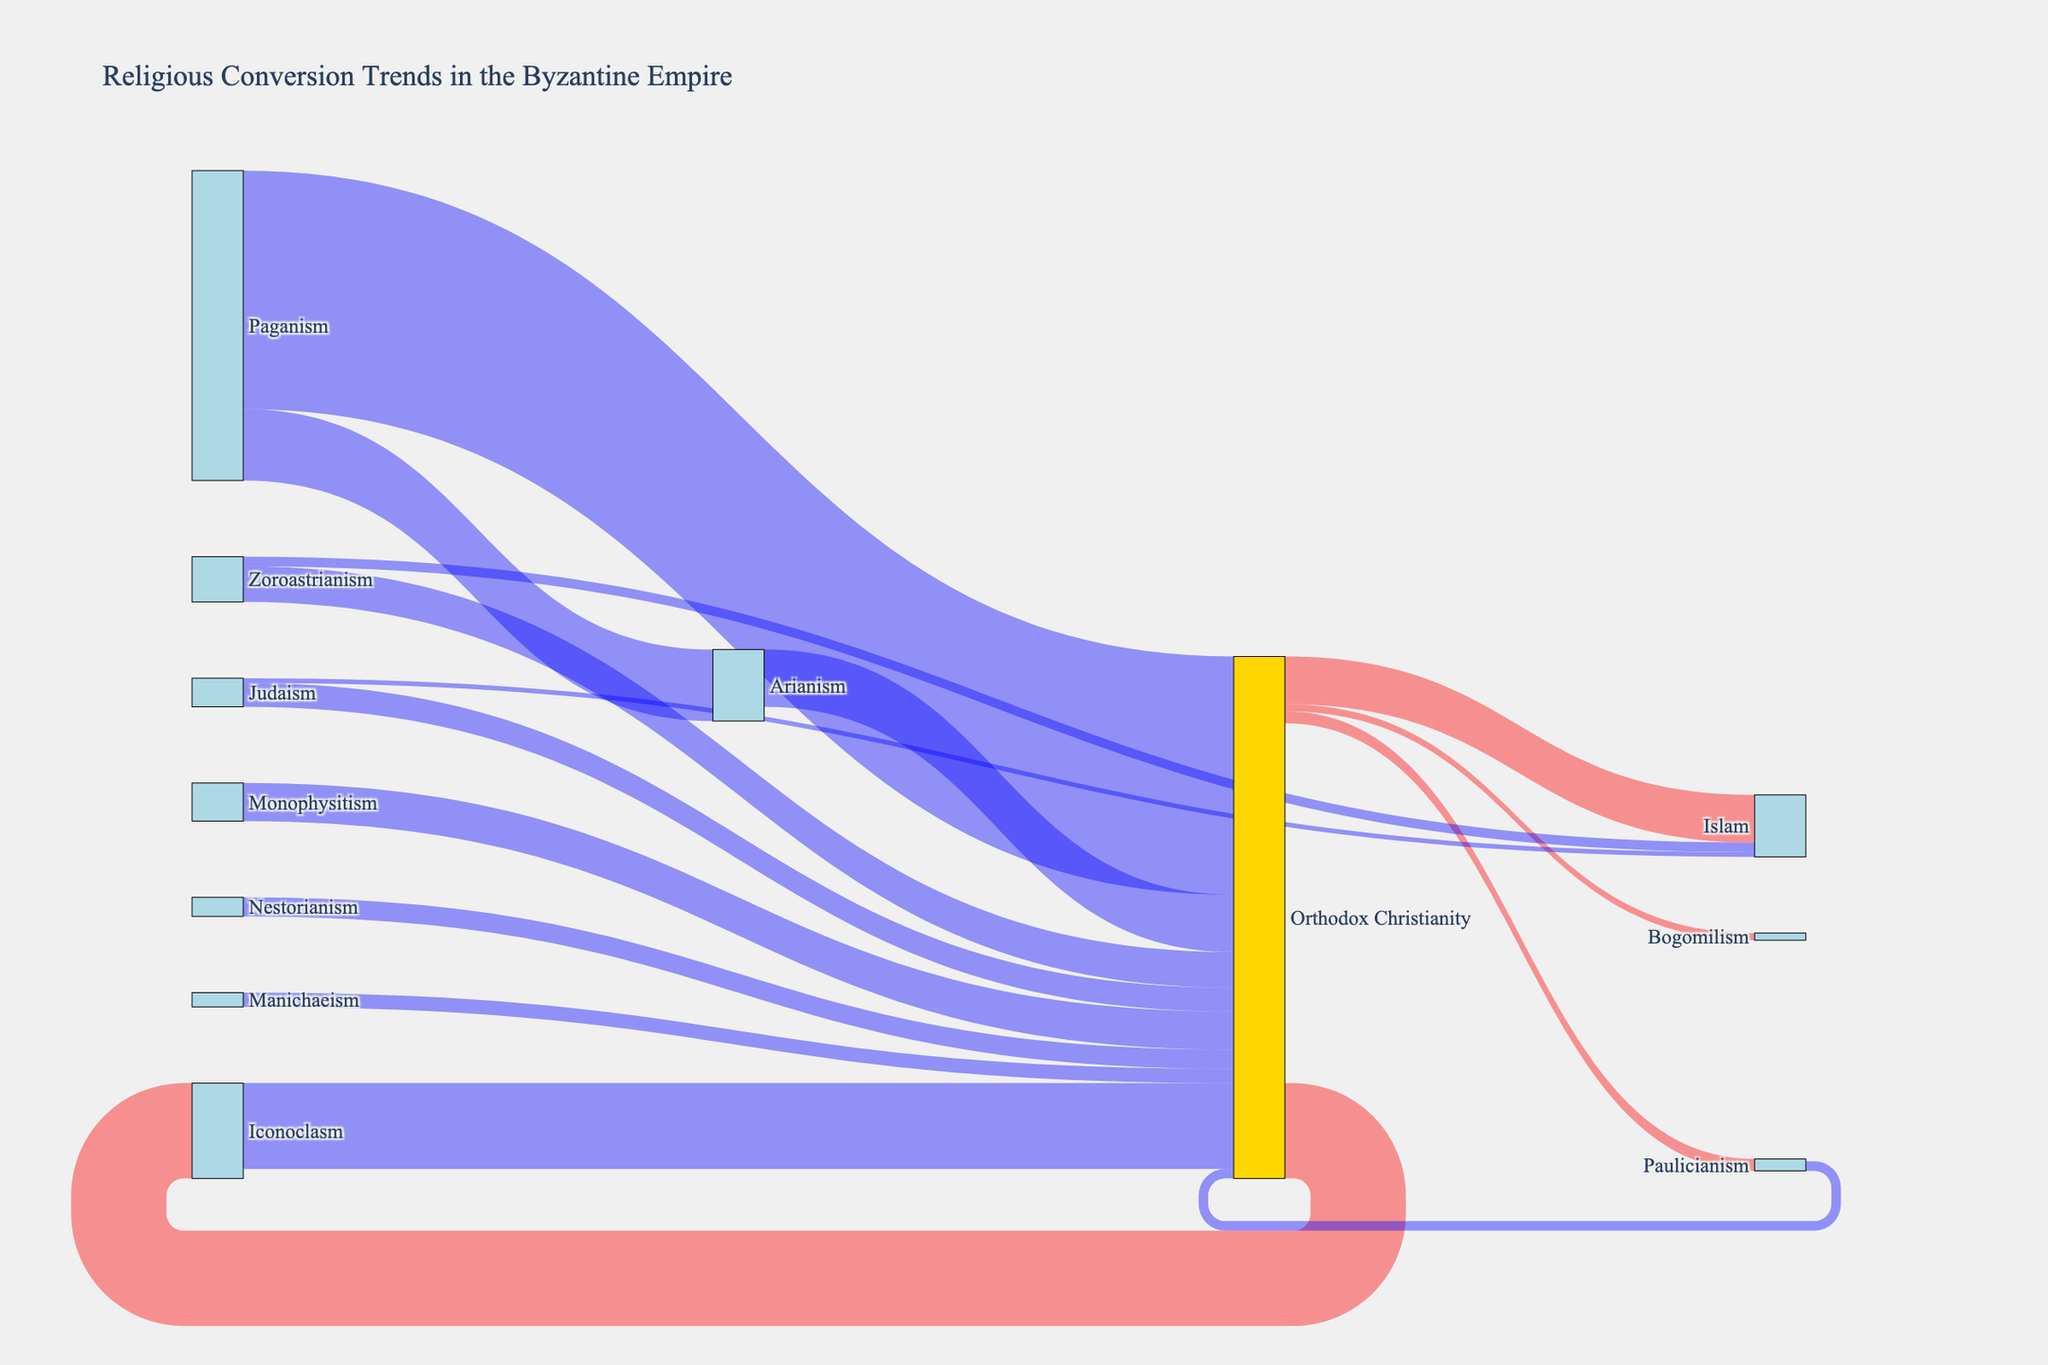What is the title of the figure? The title is usually displayed prominently at the top of the figure. By looking at the figure's top section, you can read the title.
Answer: Religious Conversion Trends in the Byzantine Empire Which religion experienced the largest conversion to Orthodox Christianity? By examining the width of the flows going into Orthodox Christianity, the largest flow comes from Paganism.
Answer: Paganism How many people converted from Orthodox Christianity to Islam? Look at the flow labeled 'Orthodox Christianity' leading to 'Islam' and see the value associated with it. It shows 100000 people.
Answer: 100000 What is the total number of people who converted to Islam, from all sources? Sum up the values of all flows leading to 'Islam': 100000 (Orthodox Christianity) + 10000 (Judaism) + 20000 (Zoroastrianism).
Answer: 130000 Compare the number of people who left Paganism to the number of people who left Orthodox Christianity. Which group was larger? Sum the values of all flows leaving Paganism and compare it to the sum of all flows leaving Orthodox Christianity. Paganism: 500000 + 150000 = 650000; Orthodox Christianity: 100000 + 200000 + 25000 + 15000 = 340000. Paganism has a larger number.
Answer: Paganism Through which minor religions did Orthodox Christianity see a return flow, and how many people converted back? Look for flows returning to 'Orthodox Christianity' from smaller religions and sum the values. Iconoclasm: 180000; Paulicianism: 20000. Sum them up: 180000 + 20000.
Answer: 200000 Which two religions had populations converting into both Orthodox Christianity and Islam? Identify religions from the diagram with flows leading to both 'Orthodox Christianity' and 'Islam'. Judaism and Zoroastrianism have such flows.
Answer: Judaism and Zoroastrianism Did more people convert from Nestorianism or Monophysitism to Orthodox Christianity? Compare the values of the flows from Nestorianism (40000) and Monophysitism (80000) to Orthodox Christianity.
Answer: Monophysitism What is the total number of people who converted to Orthodox Christianity from all other religions? Sum up all the values of flows leading to 'Orthodox Christianity' from other religions: 500000 + 150000 + 50000 + 75000 + 30000 + 120000 + 40000 + 80000.
Answer: 1265000 What is the difference in conversion numbers between Paganism to Orthodox Christianity and Arianism to Orthodox Christianity? Subtract the value of the flow from Arianism to Orthodox Christianity (120000) from the value of the flow from Paganism to Orthodox Christianity (500000).
Answer: 380000 